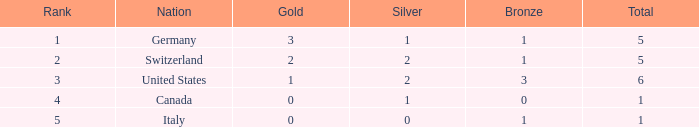How many golds for nations with over 0 silvers, over 1 total, and over 3 bronze? 0.0. 